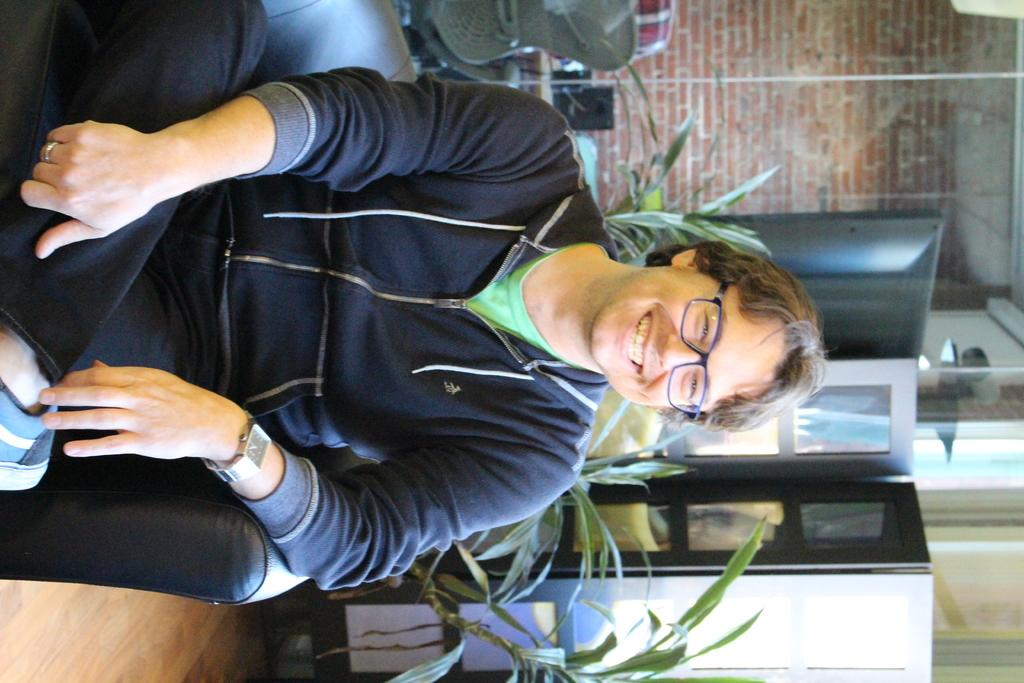Who or what is present in the image? There is a person in the image. What is the person doing in the image? The person is sitting on a sofa. What is the person's facial expression in the image? The person is smiling. What type of glue can be seen on the person's hands in the image? There is no glue present on the person's hands in the image. 